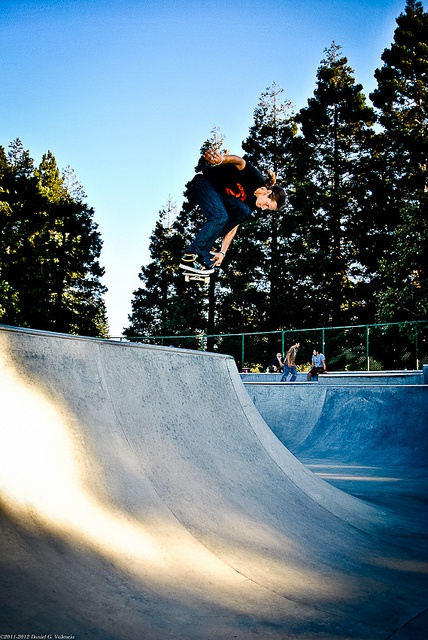Describe the objects in this image and their specific colors. I can see people in gray, black, navy, tan, and lightgray tones, people in gray, black, navy, and blue tones, people in gray, black, darkgray, and lightblue tones, skateboard in gray, ivory, black, and darkgray tones, and people in gray, black, lightgray, and darkgray tones in this image. 